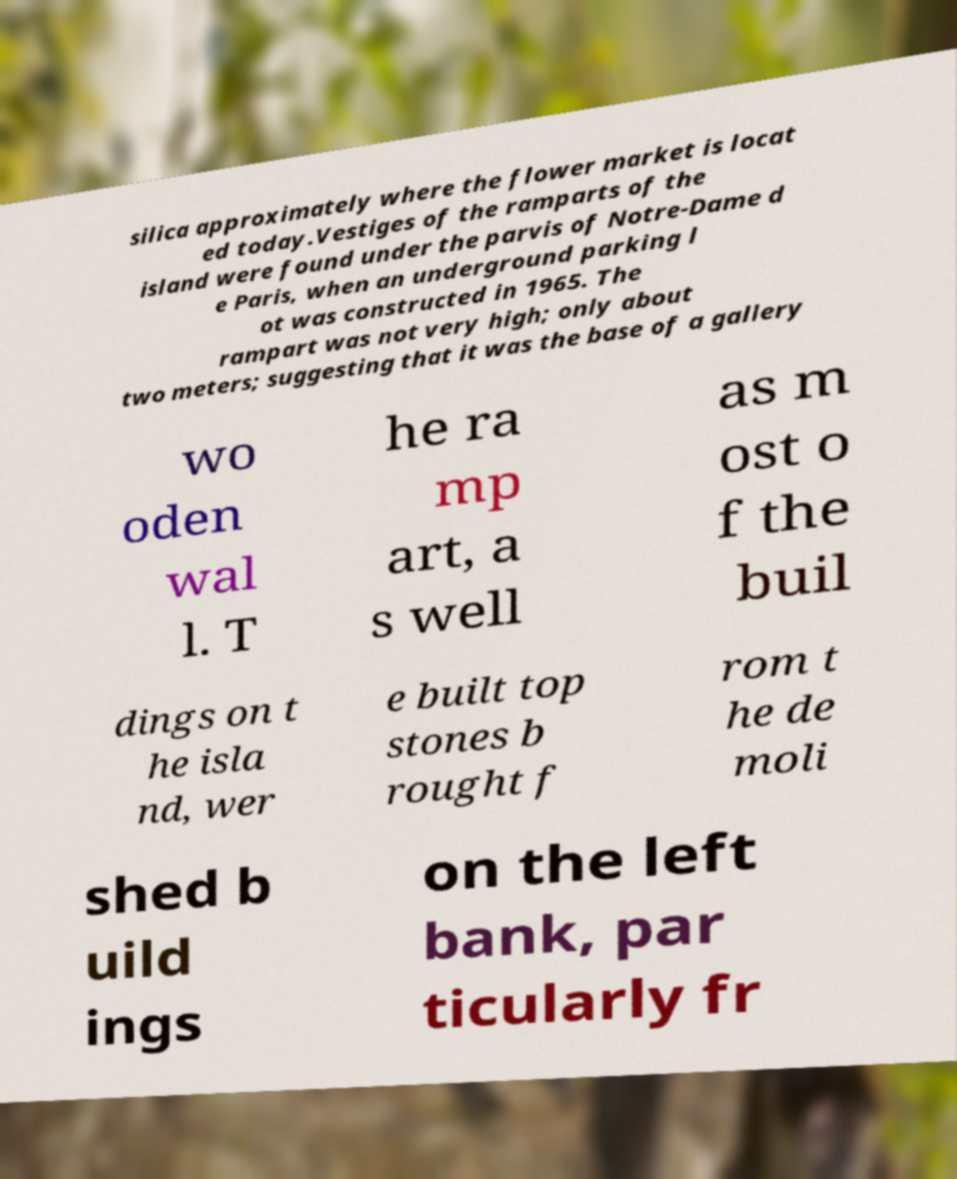Can you accurately transcribe the text from the provided image for me? silica approximately where the flower market is locat ed today.Vestiges of the ramparts of the island were found under the parvis of Notre-Dame d e Paris, when an underground parking l ot was constructed in 1965. The rampart was not very high; only about two meters; suggesting that it was the base of a gallery wo oden wal l. T he ra mp art, a s well as m ost o f the buil dings on t he isla nd, wer e built top stones b rought f rom t he de moli shed b uild ings on the left bank, par ticularly fr 